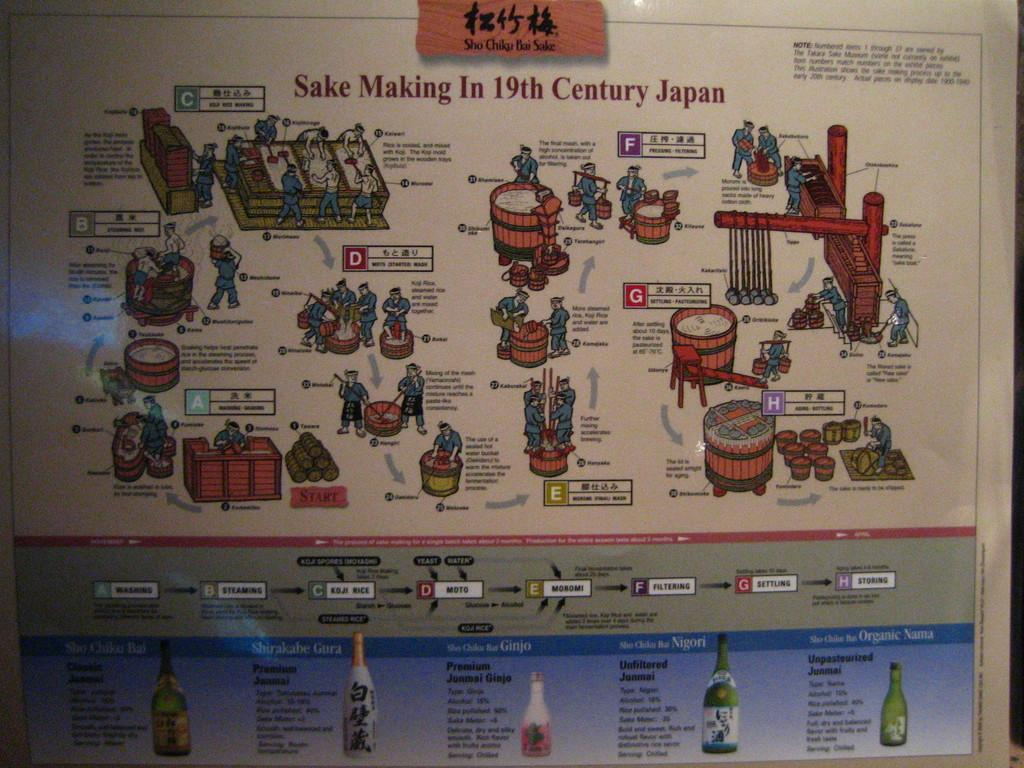<image>
Provide a brief description of the given image. A sign showing and describing the steps involved in make sake in 19th century Japan. 